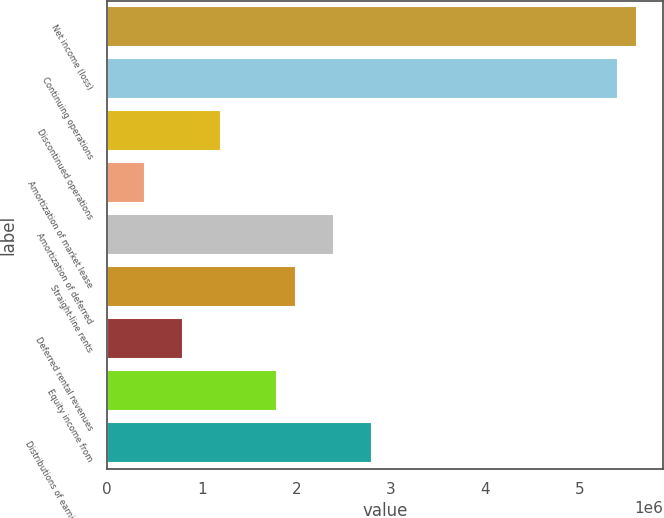Convert chart. <chart><loc_0><loc_0><loc_500><loc_500><bar_chart><fcel>Net income (loss)<fcel>Continuing operations<fcel>Discontinued operations<fcel>Amortization of market lease<fcel>Amortization of deferred<fcel>Straight-line rents<fcel>Deferred rental revenues<fcel>Equity income from<fcel>Distributions of earnings from<nl><fcel>5.59966e+06<fcel>5.39968e+06<fcel>1.20008e+06<fcel>400150<fcel>2.39996e+06<fcel>2e+06<fcel>800113<fcel>1.80002e+06<fcel>2.79992e+06<nl></chart> 